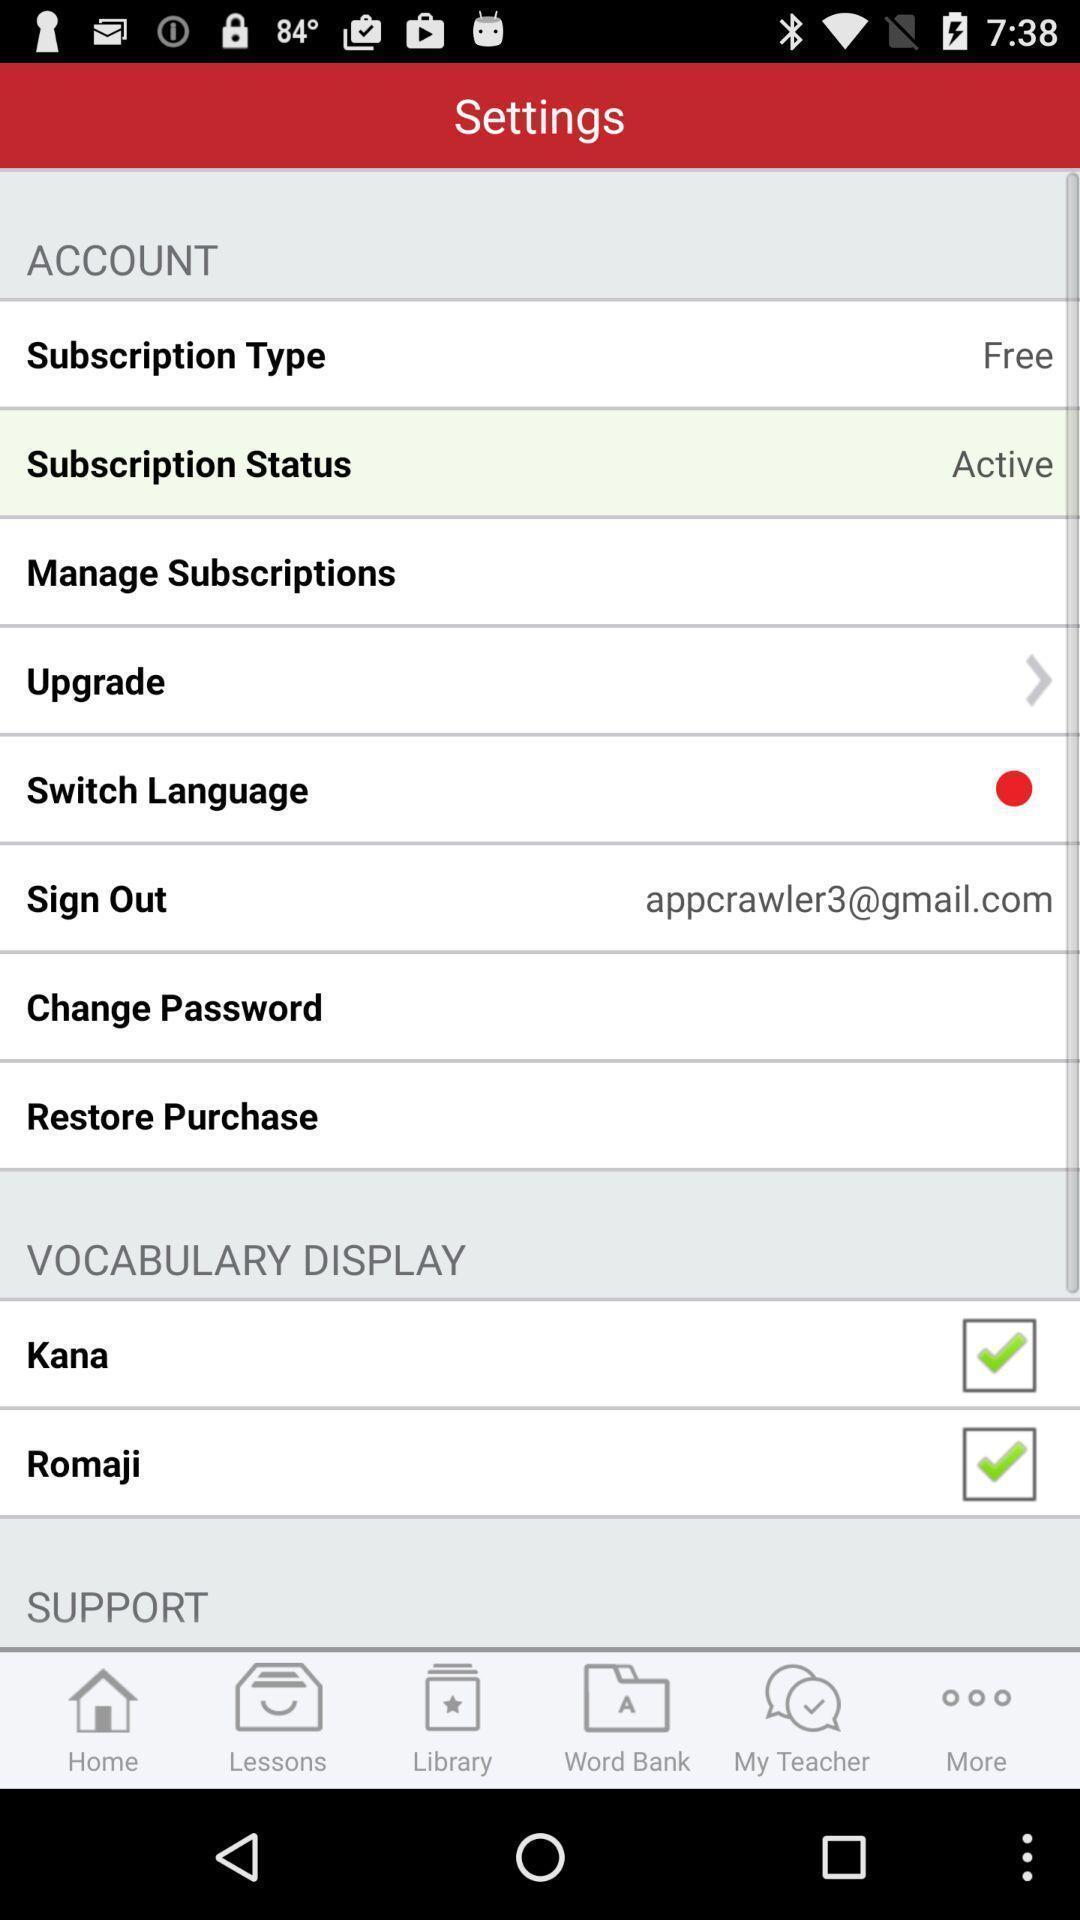Provide a description of this screenshot. Screen showing settings page of a learning app. 